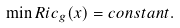<formula> <loc_0><loc_0><loc_500><loc_500>\min R i c _ { g } ( x ) = c o n s t a n t .</formula> 